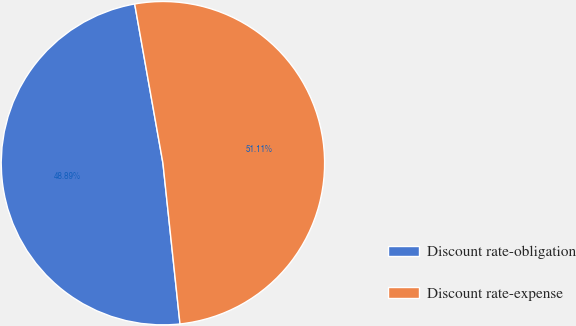Convert chart to OTSL. <chart><loc_0><loc_0><loc_500><loc_500><pie_chart><fcel>Discount rate-obligation<fcel>Discount rate-expense<nl><fcel>48.89%<fcel>51.11%<nl></chart> 